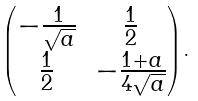Convert formula to latex. <formula><loc_0><loc_0><loc_500><loc_500>\begin{pmatrix} - \frac { 1 } { \sqrt { a } } & \frac { 1 } { 2 } \\ \frac { 1 } { 2 } & - \frac { 1 + a } { 4 \sqrt { a } } \end{pmatrix} .</formula> 